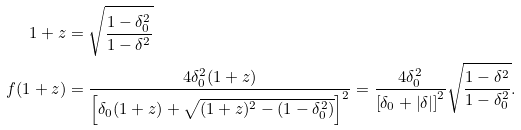<formula> <loc_0><loc_0><loc_500><loc_500>1 + z & = \sqrt { \frac { 1 - \delta _ { 0 } ^ { 2 } } { 1 - \delta ^ { 2 } } } \\ f ( 1 + z ) & = \frac { 4 \delta _ { 0 } ^ { 2 } ( 1 + z ) } { \left [ \delta _ { 0 } ( 1 + z ) + \sqrt { ( 1 + z ) ^ { 2 } - ( 1 - \delta _ { 0 } ^ { 2 } ) } \right ] ^ { 2 } } = \frac { 4 \delta _ { 0 } ^ { 2 } } { \left [ \delta _ { 0 } + \left | \delta \right | \right ] ^ { 2 } } \sqrt { \frac { 1 - \delta ^ { 2 } } { 1 - \delta _ { 0 } ^ { 2 } } } .</formula> 